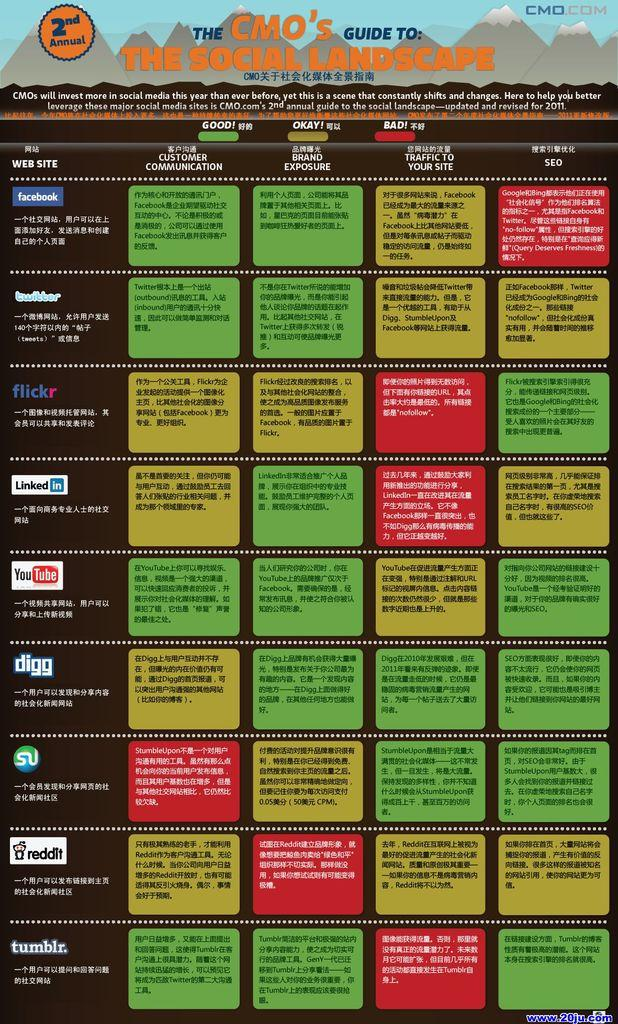What is featured on the poster in the image? There is a poster with text in the image. What can be seen on the left side of the image? There are app icons on the left side of the image. What type of landscape is depicted at the top of the image? There are images of hills at the top of the image. What is written on the hill images? There is text on the hill images. How many dimes are placed on the poster in the image? There are no dimes present in the image. What type of land is depicted in the app icons on the left side of the image? The app icons on the left side of the image do not depict any land; they are icons for apps. 